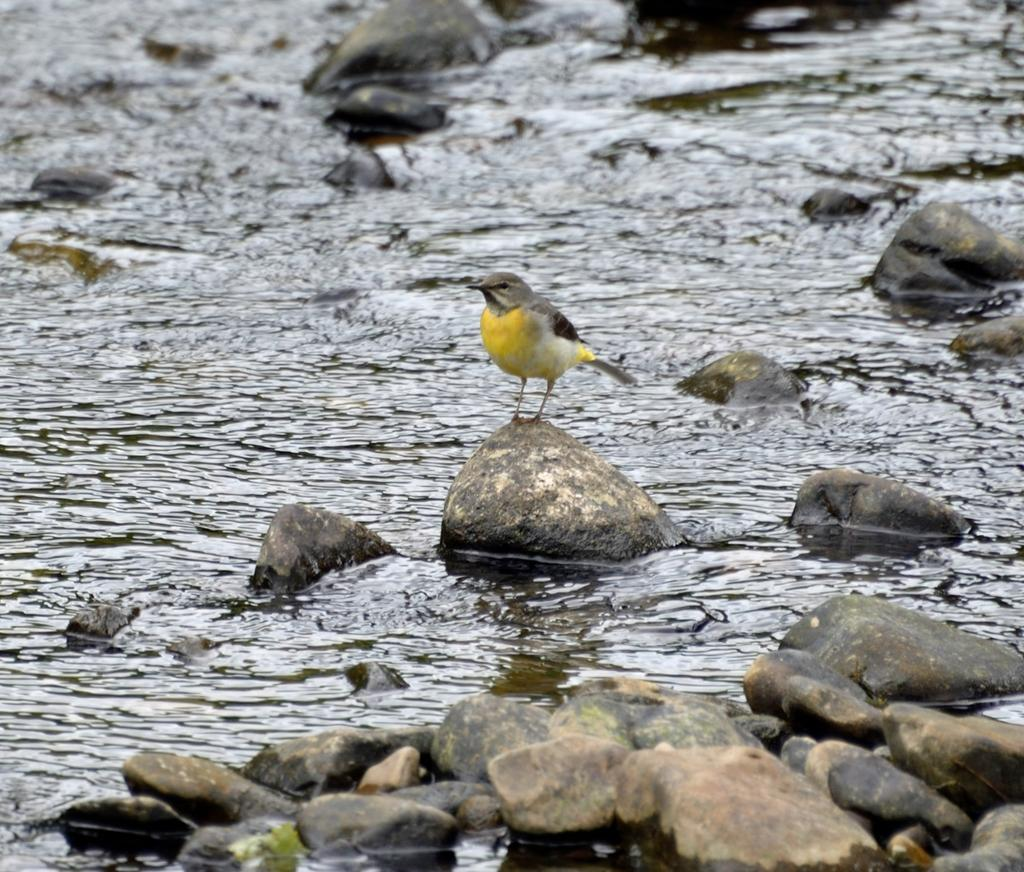What type of animal is in the image? There is a small yellow bird in the image. Where is the bird sitting? The bird is sitting on a stone. What can be seen in the background of the image? There is a river with water visible in the image. What else is present in the image besides the bird and river? There are stones present in the image. What color is the smoke coming from the bird's throat in the image? There is no smoke or flame present in the image; it features a small yellow bird sitting on a stone near a river. 